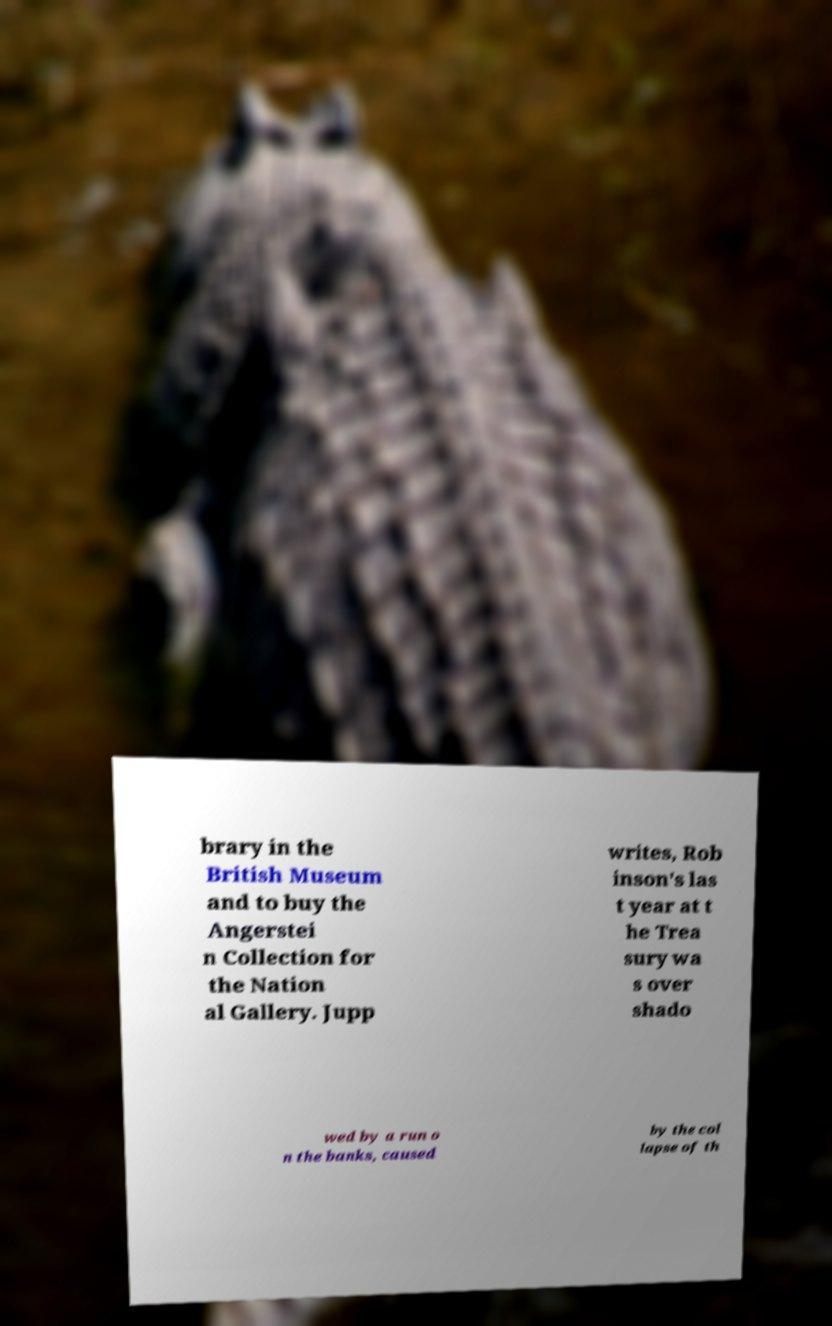I need the written content from this picture converted into text. Can you do that? brary in the British Museum and to buy the Angerstei n Collection for the Nation al Gallery. Jupp writes, Rob inson's las t year at t he Trea sury wa s over shado wed by a run o n the banks, caused by the col lapse of th 